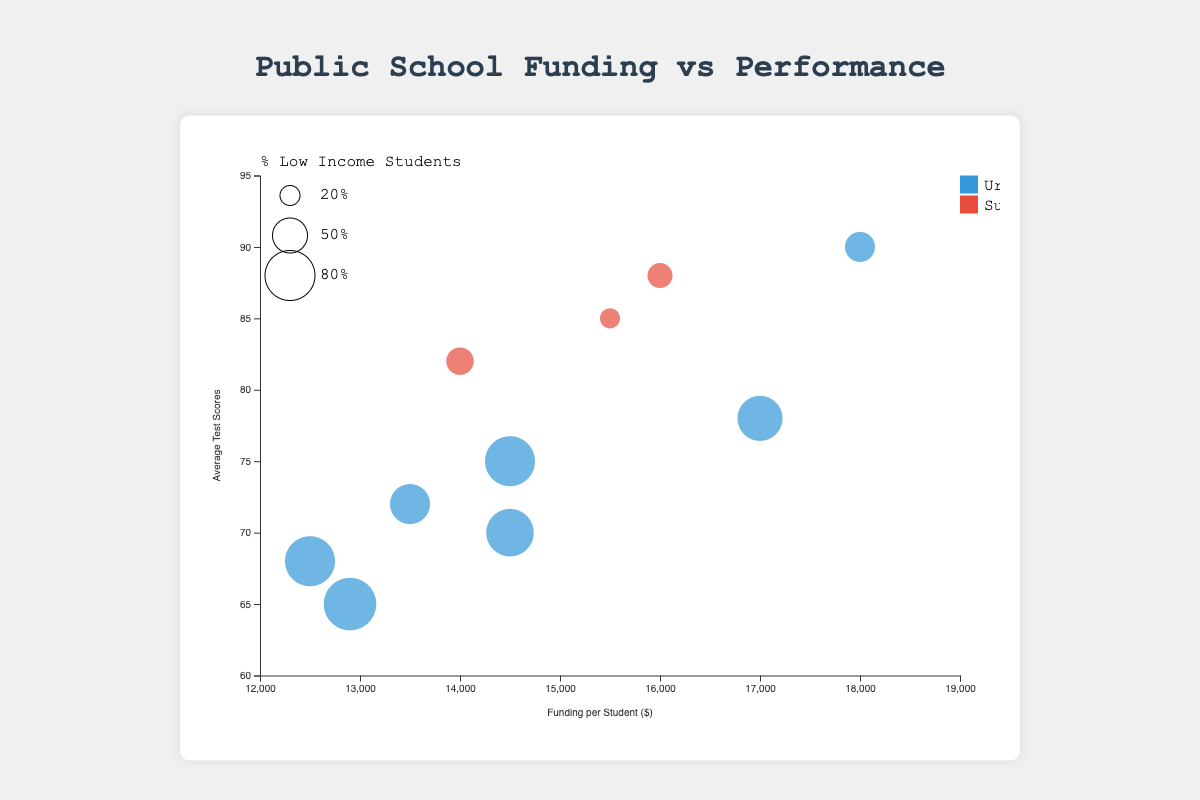What is the average test score for New York City Department of Education? From the bubble chart, locate the bubble representing "New York City Department of Education." Look at the y-axis to determine the average test scores value.
Answer: 78 Which school district has the highest funding per student? Identify the bubble that is the farthest to the right on the x-axis because the x-axis measures funding per student.
Answer: San Francisco Unified School District How many school districts are represented in the figure? Count the number of bubbles present in the chart, with each bubble representing a different school district.
Answer: 10 What is the percentage of low-income students in Detroit Public Schools? Find the bubble for "Detroit Public Schools," hover over it, or reference the tooltip to read the percentage of low-income students.
Answer: 85% Compare the funding per student between Los Angeles Unified and Chicago Public Schools, which one is greater? Check the x-axis values for both Los Angeles Unified and Chicago Public Schools. Compare their positions to see which is farther to the right.
Answer: Both are equal at $14500 What is the location type (Urban or Suburban) for Fairfax County Public Schools? Find the bubble for "Fairfax County Public Schools" and reference its color to determine whether it represents an Urban or Suburban area.
Answer: Suburban Between Houston Independent School District and Charlotte-Mecklenburg Schools, which has a higher average test score? Compare the y-axis positions of the bubbles for Houston Independent School District and Charlotte-Mecklenburg Schools.
Answer: Charlotte-Mecklenburg Schools Which urban school district has the highest average test scores? Look at the bubbles with the color representing Urban locations, then identify the one highest on the y-axis.
Answer: San Francisco Unified School District What is the difference in funding between Montgomery County Public Schools and Gwinnett County Public Schools? Find the x-axis values for both Montgomery County Public Schools and Gwinnett County Public Schools, then subtract one from the other. $16000 - $14000 = $2000
Answer: $2000 If we categorize schools with 70% or more low-income students as high-poverty, how many high-poverty school districts are in the chart? Identify bubbles representing school districts with "PercentLowIncomeStudents" values equal to or greater than 70% and count them.
Answer: 6 